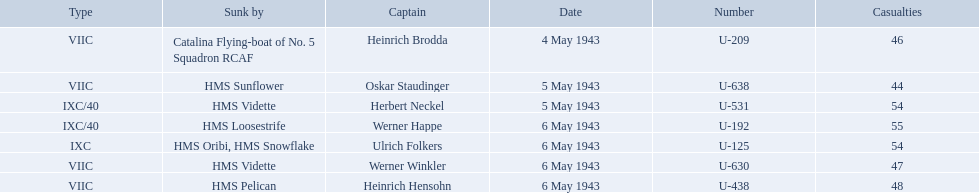What boats were lost on may 5? U-638, U-531. Who were the captains of those boats? Oskar Staudinger, Herbert Neckel. Which captain was not oskar staudinger? Herbert Neckel. 